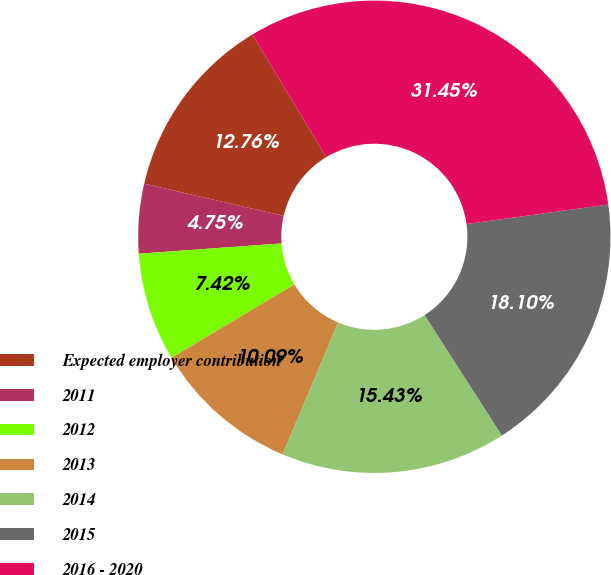<chart> <loc_0><loc_0><loc_500><loc_500><pie_chart><fcel>Expected employer contribution<fcel>2011<fcel>2012<fcel>2013<fcel>2014<fcel>2015<fcel>2016 - 2020<nl><fcel>12.76%<fcel>4.75%<fcel>7.42%<fcel>10.09%<fcel>15.43%<fcel>18.1%<fcel>31.45%<nl></chart> 